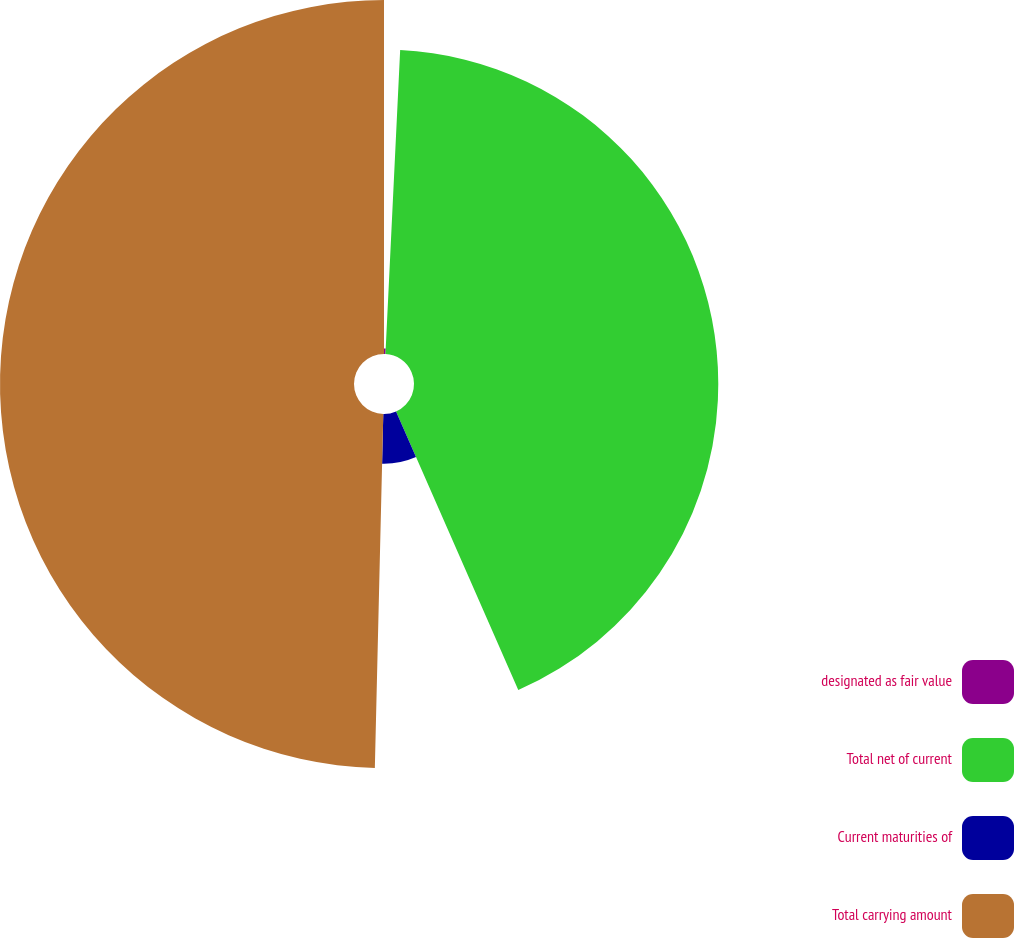<chart> <loc_0><loc_0><loc_500><loc_500><pie_chart><fcel>designated as fair value<fcel>Total net of current<fcel>Current maturities of<fcel>Total carrying amount<nl><fcel>0.77%<fcel>42.65%<fcel>6.96%<fcel>49.62%<nl></chart> 